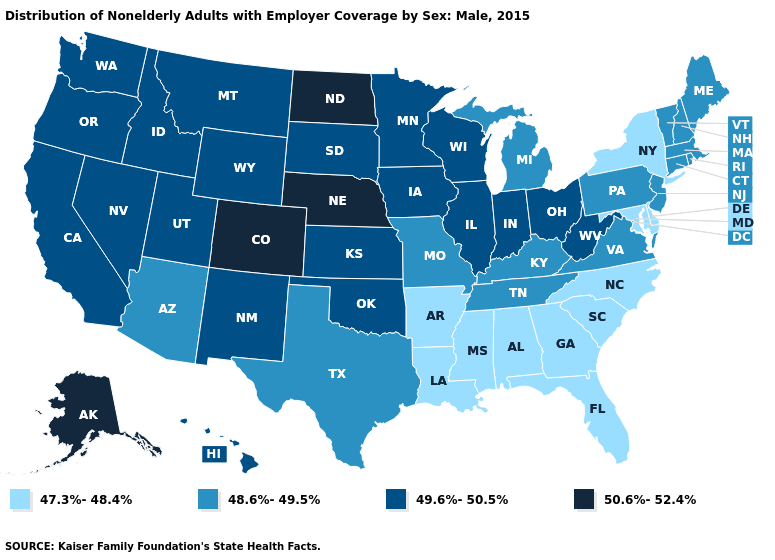What is the value of Arkansas?
Give a very brief answer. 47.3%-48.4%. What is the highest value in the USA?
Answer briefly. 50.6%-52.4%. Which states have the lowest value in the USA?
Be succinct. Alabama, Arkansas, Delaware, Florida, Georgia, Louisiana, Maryland, Mississippi, New York, North Carolina, South Carolina. Does Massachusetts have a lower value than Wisconsin?
Answer briefly. Yes. Does North Dakota have the highest value in the MidWest?
Quick response, please. Yes. Does Illinois have the lowest value in the USA?
Be succinct. No. How many symbols are there in the legend?
Quick response, please. 4. What is the lowest value in states that border Virginia?
Keep it brief. 47.3%-48.4%. Does the first symbol in the legend represent the smallest category?
Quick response, please. Yes. Which states have the lowest value in the USA?
Be succinct. Alabama, Arkansas, Delaware, Florida, Georgia, Louisiana, Maryland, Mississippi, New York, North Carolina, South Carolina. What is the value of Illinois?
Answer briefly. 49.6%-50.5%. Name the states that have a value in the range 47.3%-48.4%?
Give a very brief answer. Alabama, Arkansas, Delaware, Florida, Georgia, Louisiana, Maryland, Mississippi, New York, North Carolina, South Carolina. Does the first symbol in the legend represent the smallest category?
Be succinct. Yes. Name the states that have a value in the range 48.6%-49.5%?
Be succinct. Arizona, Connecticut, Kentucky, Maine, Massachusetts, Michigan, Missouri, New Hampshire, New Jersey, Pennsylvania, Rhode Island, Tennessee, Texas, Vermont, Virginia. 